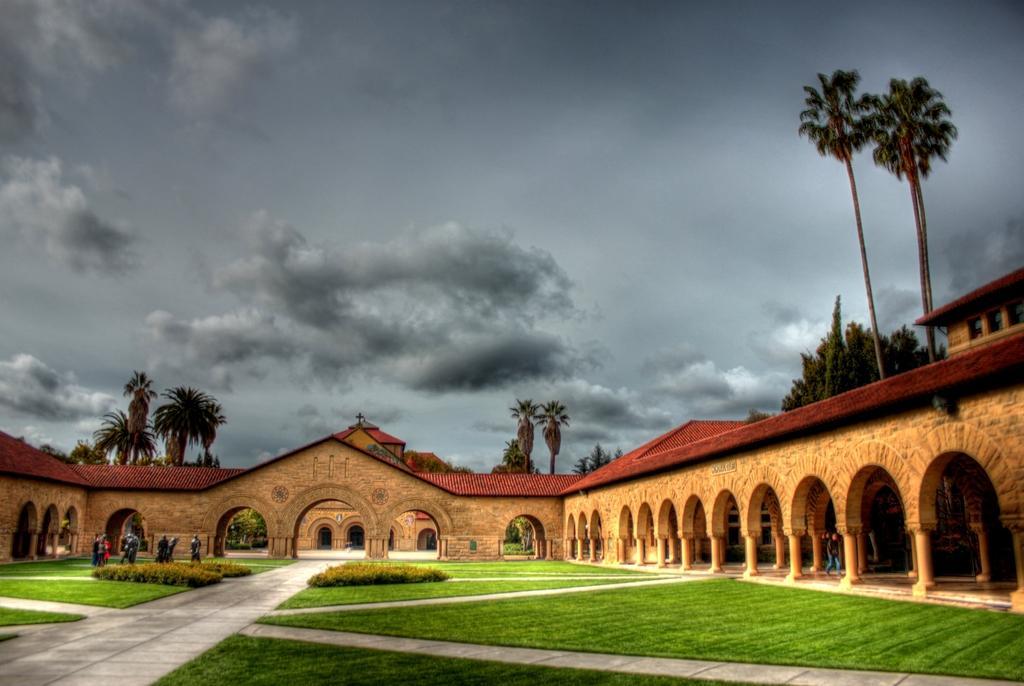Can you describe this image briefly? In this image there are buildings and we can see trees. There are people. We can see shrubs. In the background there is sky. 